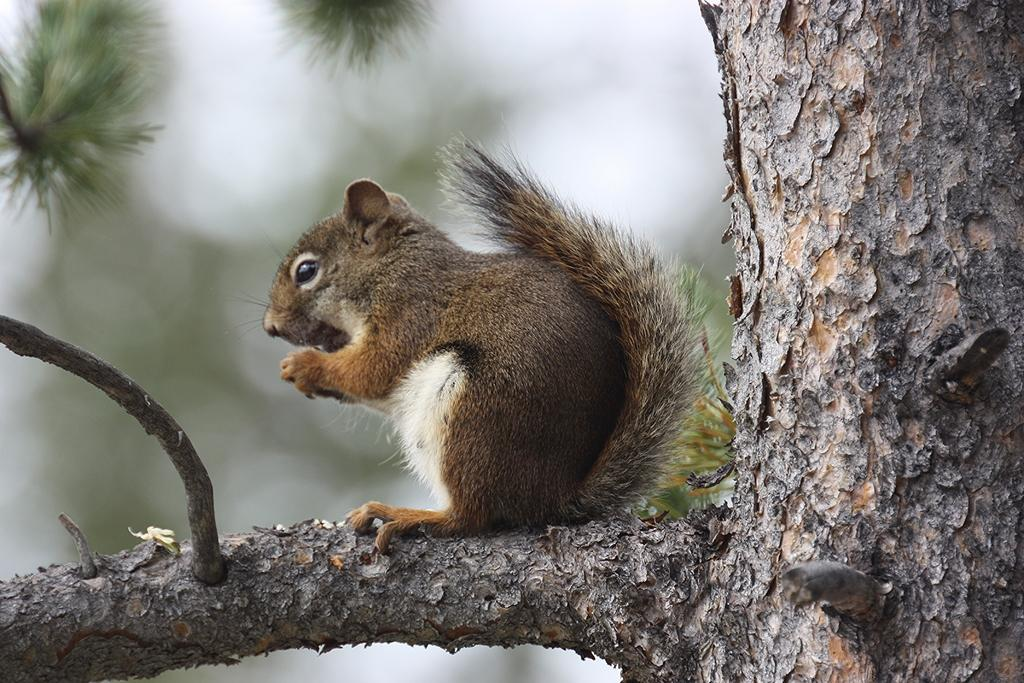What animal can be seen in the image? There is a squirrel in the image. Where is the squirrel located? The squirrel is sitting on the tree stem. What can be seen at the top of the tree in the image? There are green leaves at the top of the tree in the image. What type of trousers is the owl wearing in the image? There is no owl present in the image, and therefore no trousers to describe. 